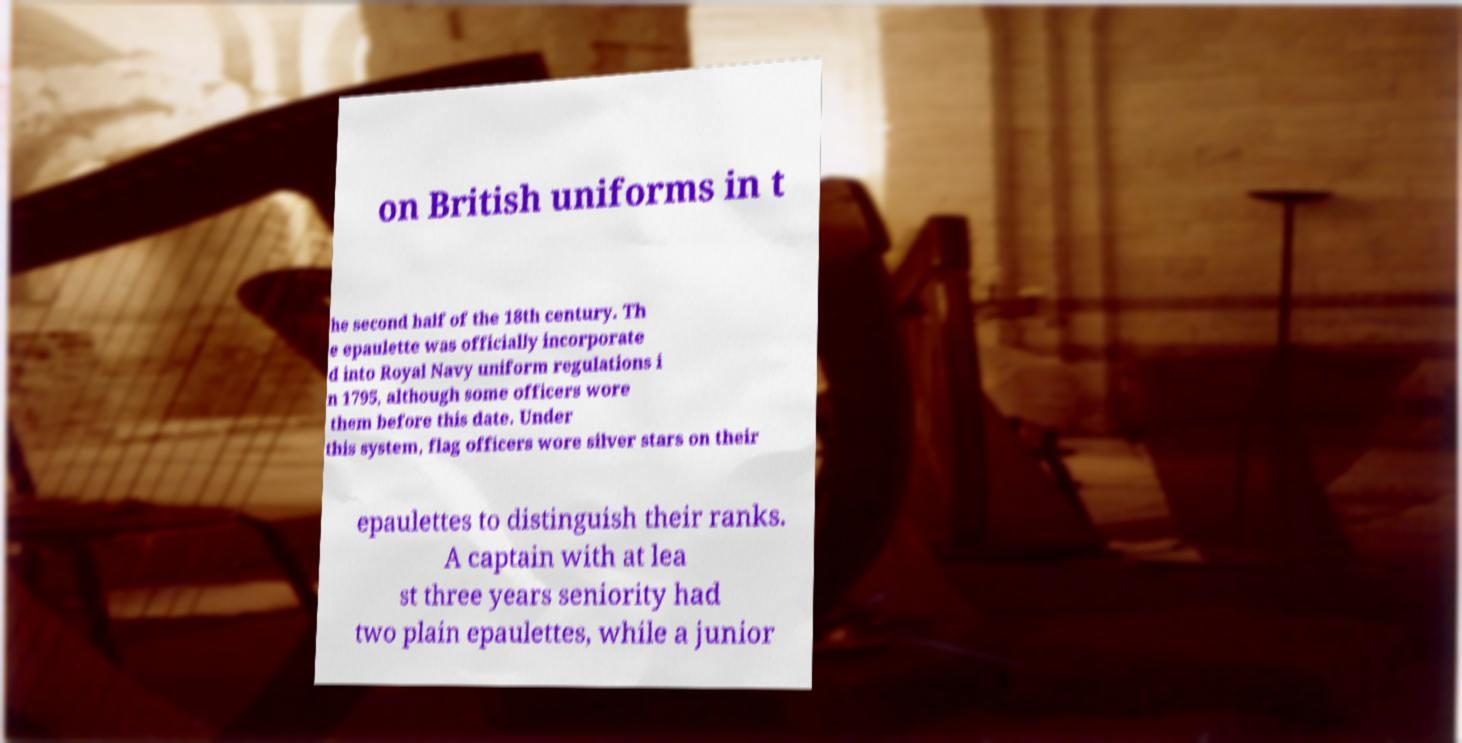I need the written content from this picture converted into text. Can you do that? on British uniforms in t he second half of the 18th century. Th e epaulette was officially incorporate d into Royal Navy uniform regulations i n 1795, although some officers wore them before this date. Under this system, flag officers wore silver stars on their epaulettes to distinguish their ranks. A captain with at lea st three years seniority had two plain epaulettes, while a junior 